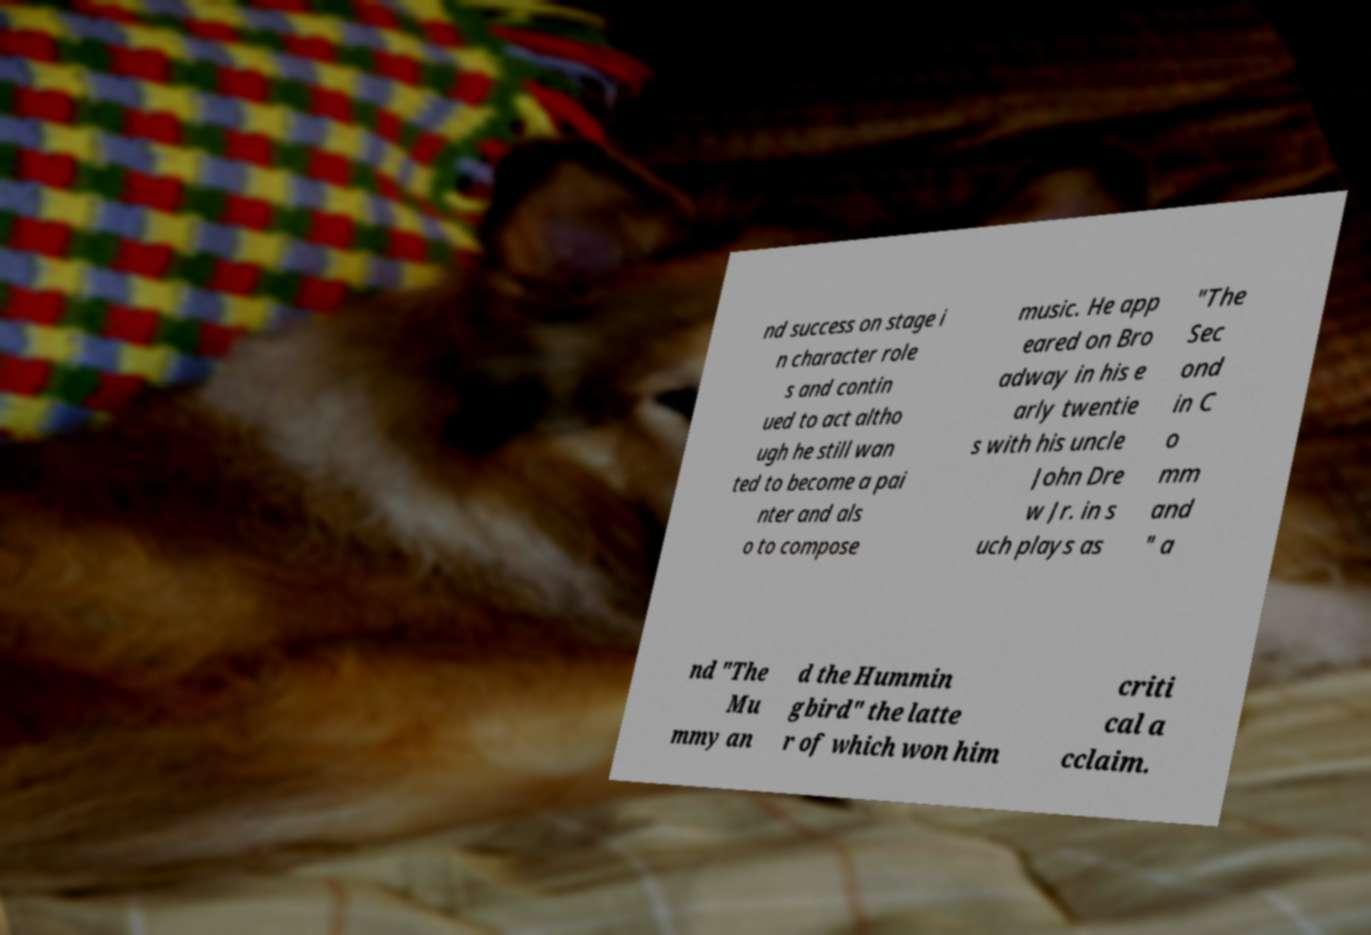Can you accurately transcribe the text from the provided image for me? nd success on stage i n character role s and contin ued to act altho ugh he still wan ted to become a pai nter and als o to compose music. He app eared on Bro adway in his e arly twentie s with his uncle John Dre w Jr. in s uch plays as "The Sec ond in C o mm and " a nd "The Mu mmy an d the Hummin gbird" the latte r of which won him criti cal a cclaim. 